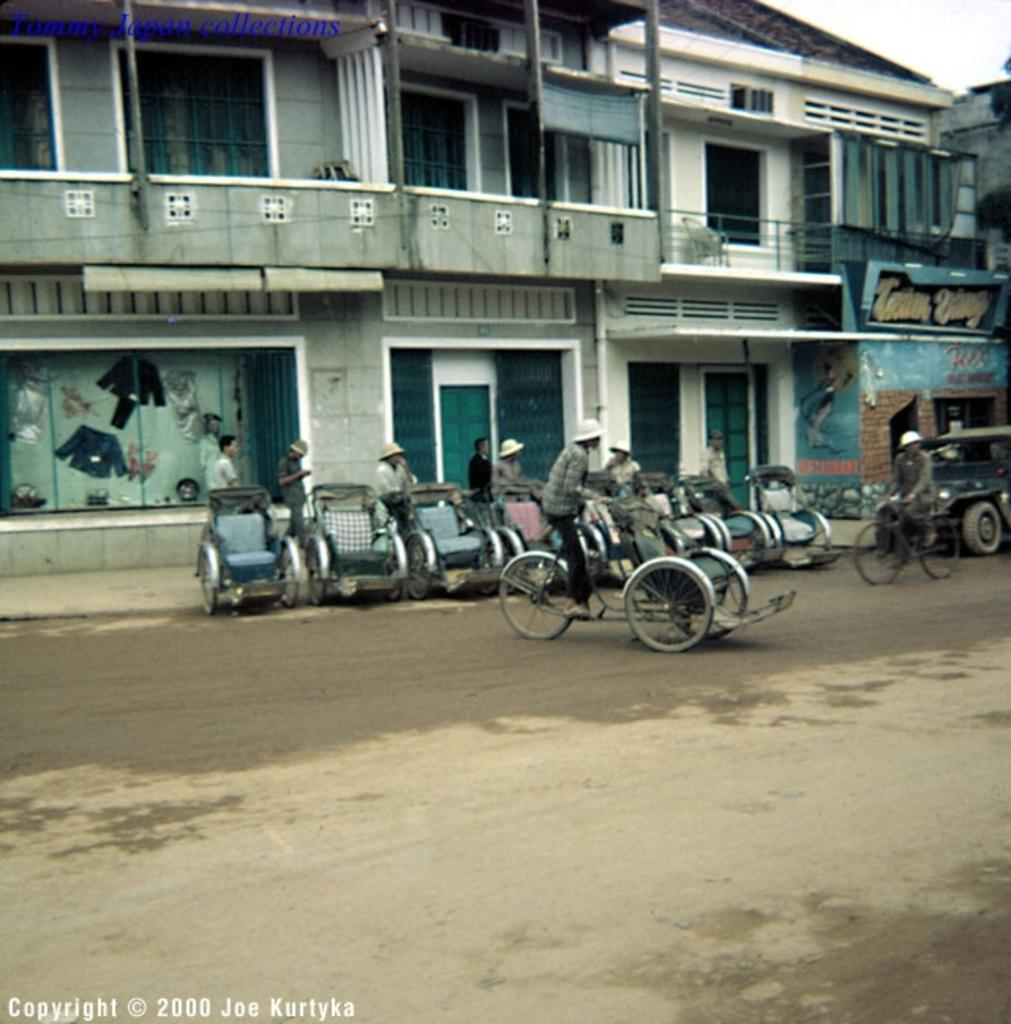What type of structure is visible in the image? There is a building in the image. What features can be seen on the building? The building has windows and a door. Who or what is present in the image besides the building? There are people and vehicles in the image. What type of jewel is being processed by the people in the image? There is no mention of a jewel or any processing activity in the image; it features a building with windows and a door, along with people and vehicles. 